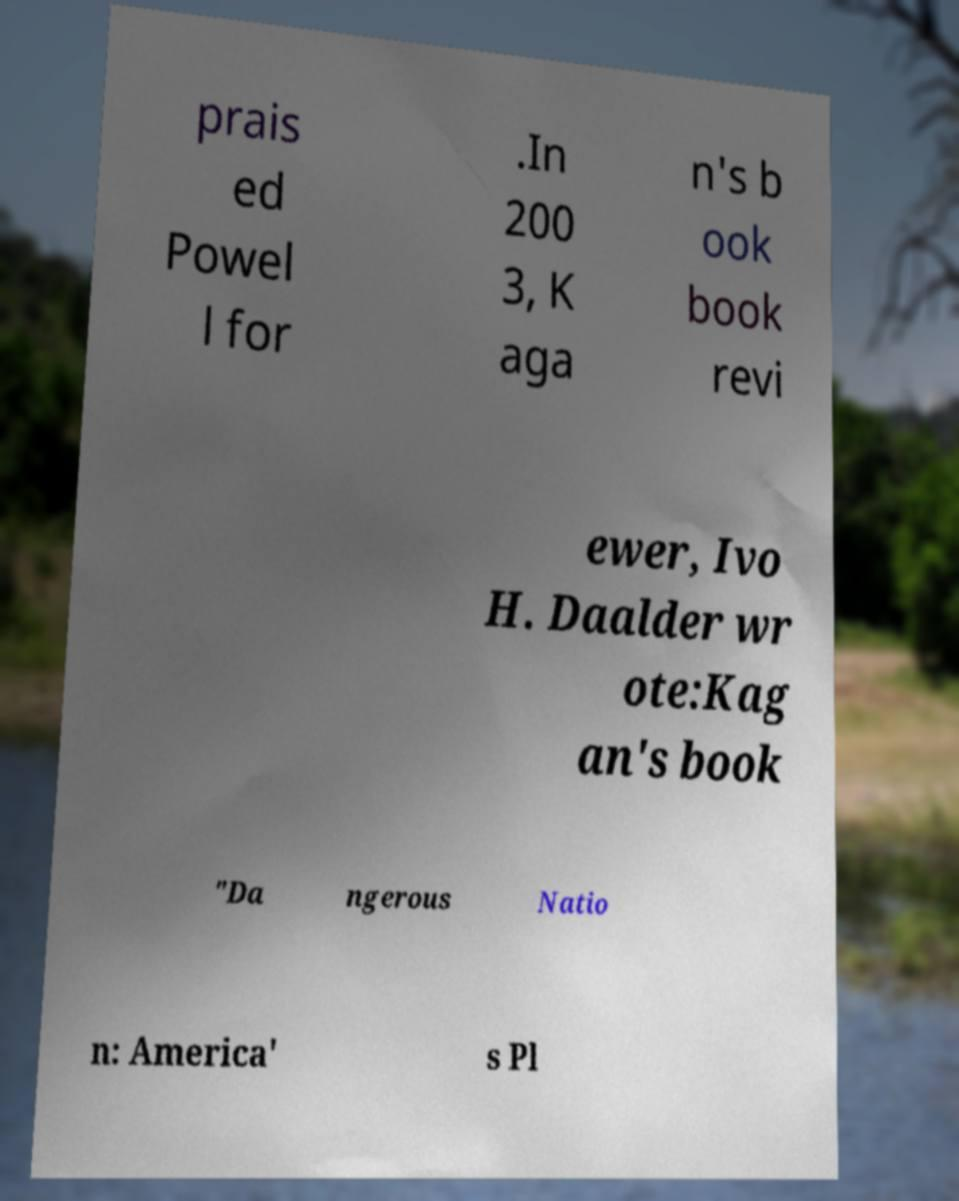Can you accurately transcribe the text from the provided image for me? prais ed Powel l for .In 200 3, K aga n's b ook book revi ewer, Ivo H. Daalder wr ote:Kag an's book "Da ngerous Natio n: America' s Pl 